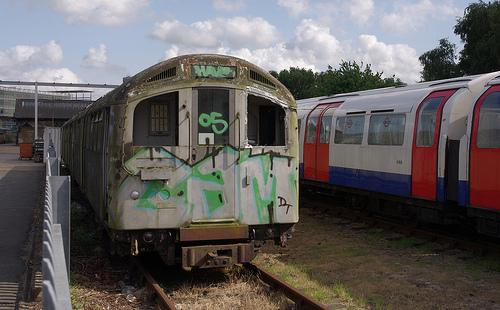Give a brief overview of the scene involving the trains. There is an old train and a newer train on the tracks, with rusted metal, graffiti, and green lettering on the old train and large windows on the newer train. 